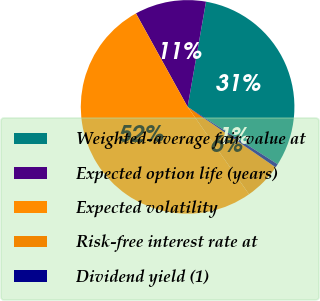Convert chart. <chart><loc_0><loc_0><loc_500><loc_500><pie_chart><fcel>Weighted-average fair value at<fcel>Expected option life (years)<fcel>Expected volatility<fcel>Risk-free interest rate at<fcel>Dividend yield (1)<nl><fcel>31.27%<fcel>10.79%<fcel>51.72%<fcel>5.67%<fcel>0.55%<nl></chart> 